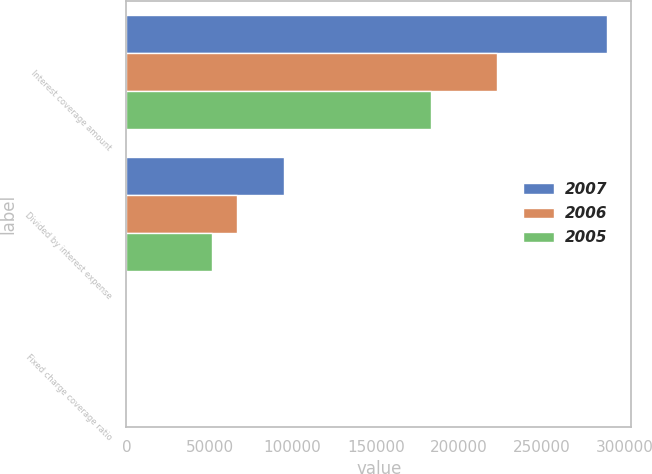Convert chart. <chart><loc_0><loc_0><loc_500><loc_500><stacked_bar_chart><ecel><fcel>Interest coverage amount<fcel>Divided by interest expense<fcel>Fixed charge coverage ratio<nl><fcel>2007<fcel>289413<fcel>94785<fcel>3.1<nl><fcel>2006<fcel>223139<fcel>66433<fcel>3.4<nl><fcel>2005<fcel>183222<fcel>51491<fcel>3.6<nl></chart> 